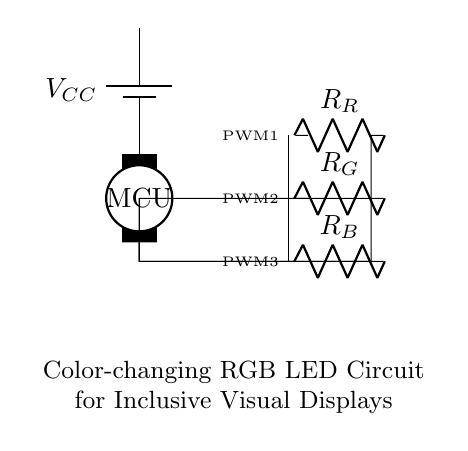What is the main component controlling the circuit? The main component is the microcontroller, which is responsible for controlling the RGB LEDs through Pulse Width Modulation (PWM) signals. It is the central part of the circuit that manages the operating states of the LEDs.
Answer: microcontroller How many RGB LEDs are in the circuit? There are three RGB LEDs in the circuit, one for each primary color: red, green, and blue. These LEDs are responsible for creating various color combinations.
Answer: three What is the function of the resistors in this circuit? The resistors limit the current flowing through each LED, protecting them from excessive current which could cause damage. Each resistor is specifically assigned to one of the RGB LEDs.
Answer: limit current What type of signals do the LEDs receive from the microcontroller? The LEDs receive Pulse Width Modulation (PWM) signals from the microcontroller, which allows for varying brightness levels and color mixing through controlling the duty cycle of the signals.
Answer: PWM signals What happens if the resistors are not included in the circuit? If the resistors are not included, the LEDs would likely receive too much current, which could lead to overheating and failure of the LEDs due to their inability to handle excessive current without protection.
Answer: overheating What power supply voltage is typically needed for this circuit? The typical power supply voltage in such circuits is often around 5 volts, which is a standard voltage for microcontroller-based circuits and is sufficient for driving the LEDs.
Answer: five volts 